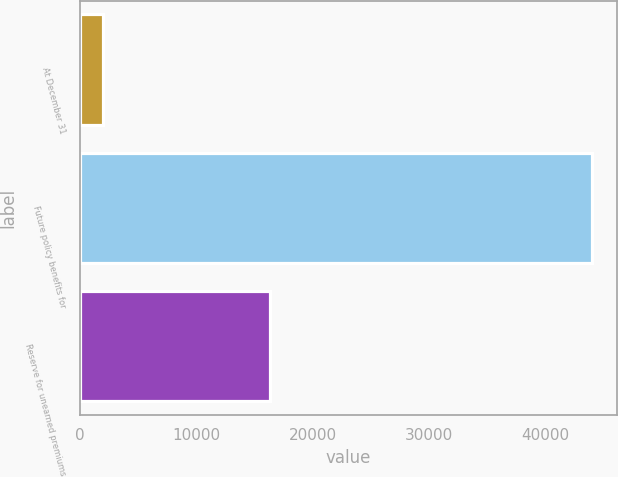<chart> <loc_0><loc_0><loc_500><loc_500><bar_chart><fcel>At December 31<fcel>Future policy benefits for<fcel>Reserve for unearned premiums<nl><fcel>2018<fcel>43936<fcel>16300<nl></chart> 